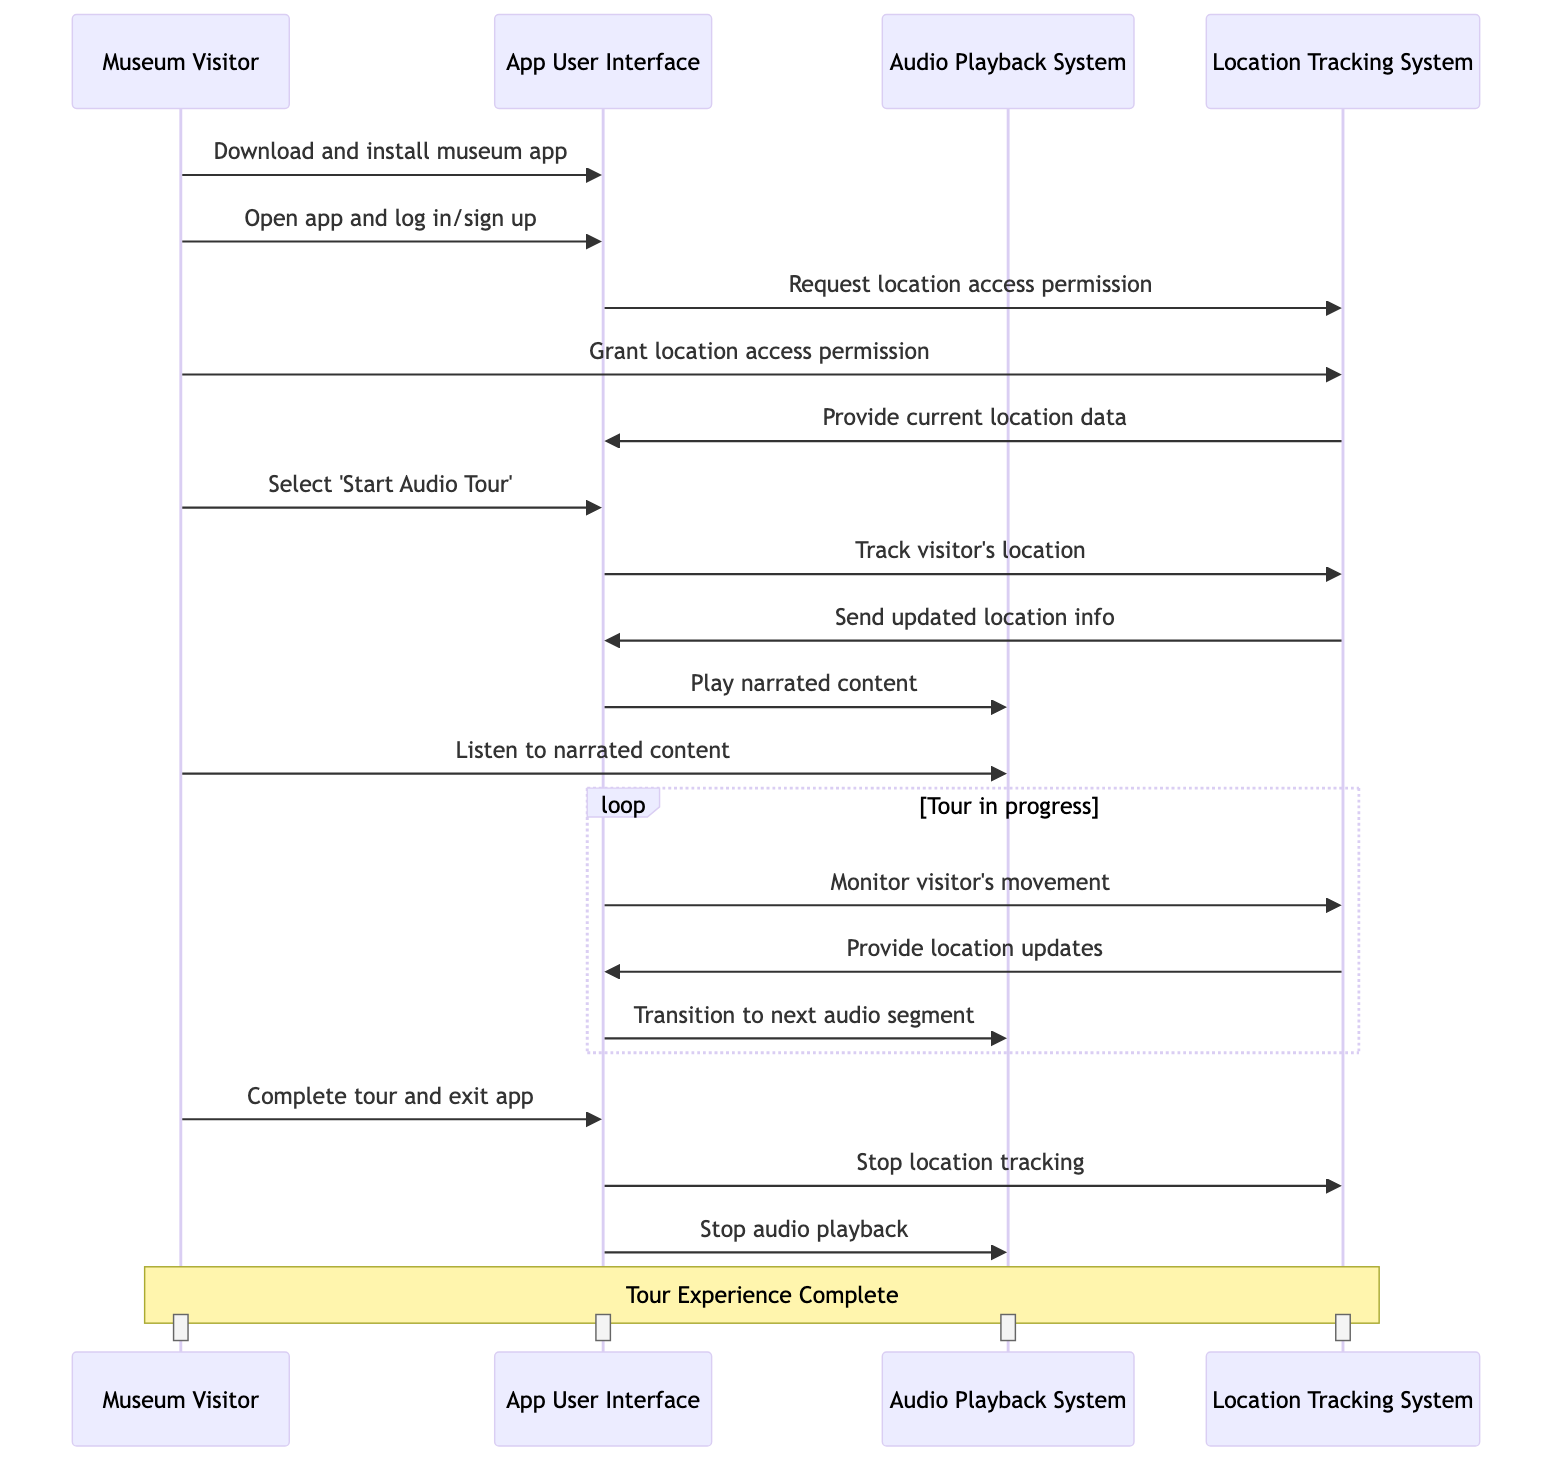What is the first action taken by the Museum Visitor? The first action is "Download and install the museum app from the App Store." This is the first message that is sent from the visitor to the app user interface in the sequence diagram.
Answer: Download and install the museum app from the App Store How many main actors are involved in this sequence? There are four main actors involved in the sequence: Museum Visitor, App User Interface, Audio Playback System, and Location Tracking System. Each of these actors plays a distinct role in the process.
Answer: Four What does the App User Interface request after the visitor opens the app? After the visitor opens the app, the App User Interface requests "location access permission" from the Location Tracking System. This is a necessary step to utilize location-based features of the app.
Answer: Request location access permission What occurs in the loop section of the diagram? In the loop section, the App User Interface monitors the visitor's movement and receives continuous location updates from the Location Tracking System. During this loop, the app transitions to the next audio segment based on the visitor's current location.
Answer: Monitor visitor's movement, Provide location updates, Transition to next audio segment What does the visitor do after completing the tour? After completing the tour, the visitor's action is to "Complete the tour and exit the app." This signals the end of the interaction with the app, wrapping up the entire experience.
Answer: Complete the tour and exit the app Which system stops audio playback at the end? The last action in the sequence for stopping audio playback is done by the App User Interface, as indicated by the message "Stop audio playback" sent to the Audio Playback System. This signifies the end of the audio tour.
Answer: App User Interface What is sent from the Location Tracking System to the App User Interface when tracking the visitor? The Location Tracking System sends "updated location and exhibit information" to the App User Interface, allowing the app to provide tailored audio content as the visitor moves through the museum.
Answer: Send updated location and exhibit information What permission must the Museum Visitor grant for the app to function properly? The Museum Visitor must grant "location access permission" to allow the app to utilize location-based features, which is crucial for the audio tour experience.
Answer: Location access permission 